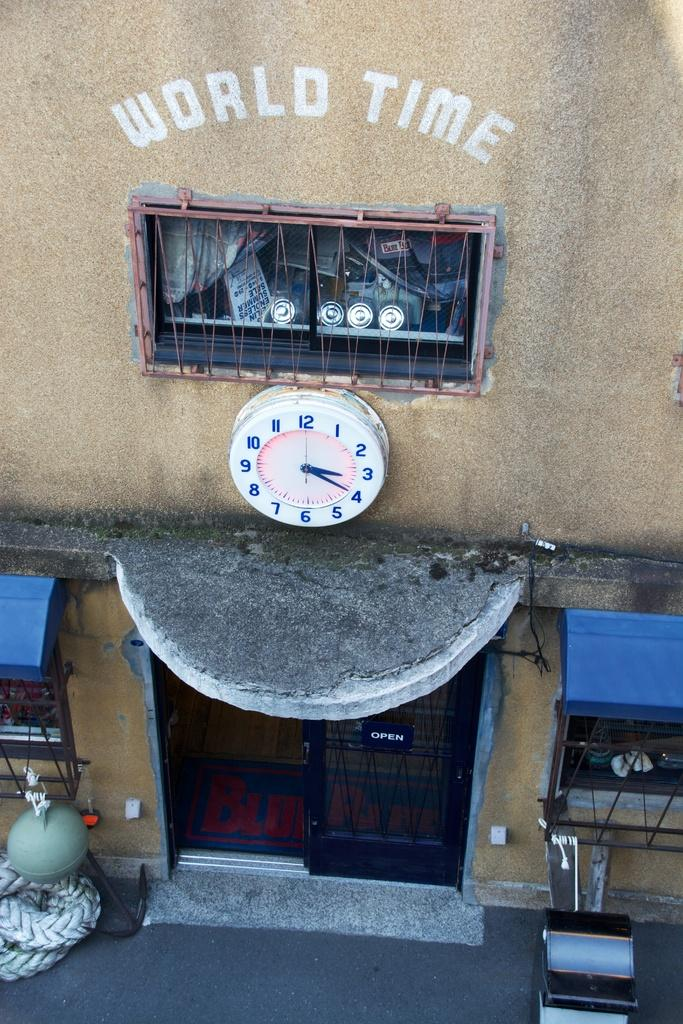Provide a one-sentence caption for the provided image. A clock with the words world time written on the wall above it. 